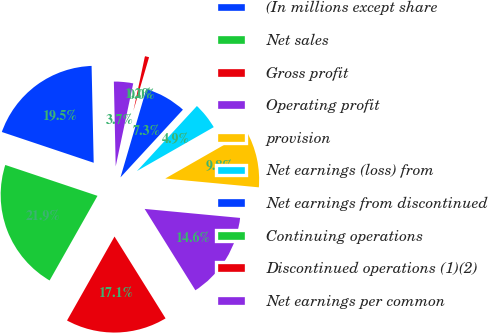Convert chart. <chart><loc_0><loc_0><loc_500><loc_500><pie_chart><fcel>(In millions except share<fcel>Net sales<fcel>Gross profit<fcel>Operating profit<fcel>provision<fcel>Net earnings (loss) from<fcel>Net earnings from discontinued<fcel>Continuing operations<fcel>Discontinued operations (1)(2)<fcel>Net earnings per common<nl><fcel>19.51%<fcel>21.95%<fcel>17.07%<fcel>14.63%<fcel>9.76%<fcel>4.88%<fcel>7.32%<fcel>0.0%<fcel>1.22%<fcel>3.66%<nl></chart> 